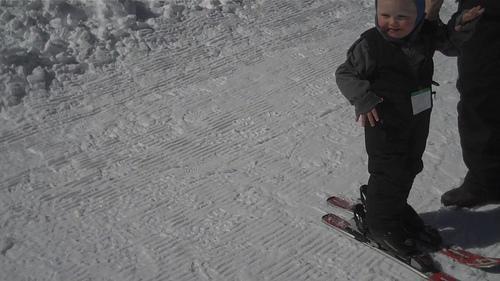How many people are partially shown?
Give a very brief answer. 2. 